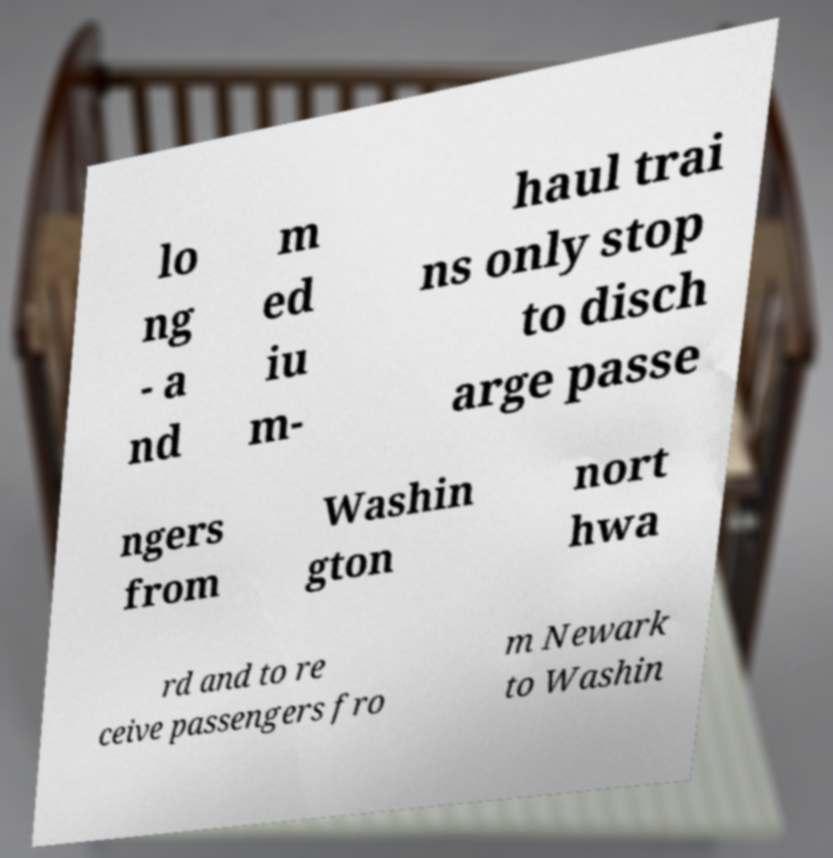Please read and relay the text visible in this image. What does it say? lo ng - a nd m ed iu m- haul trai ns only stop to disch arge passe ngers from Washin gton nort hwa rd and to re ceive passengers fro m Newark to Washin 